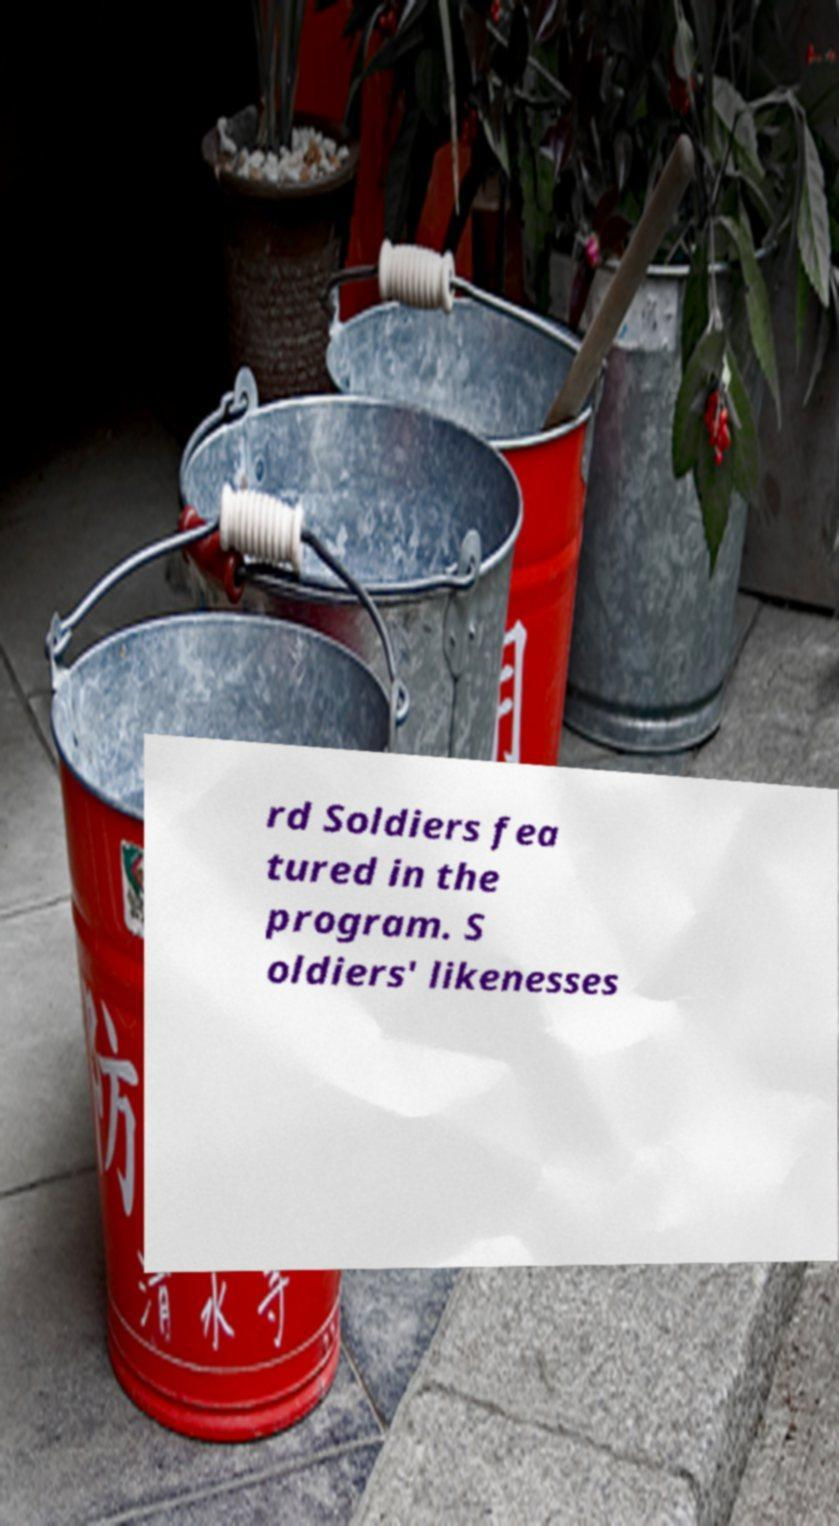Could you assist in decoding the text presented in this image and type it out clearly? rd Soldiers fea tured in the program. S oldiers' likenesses 